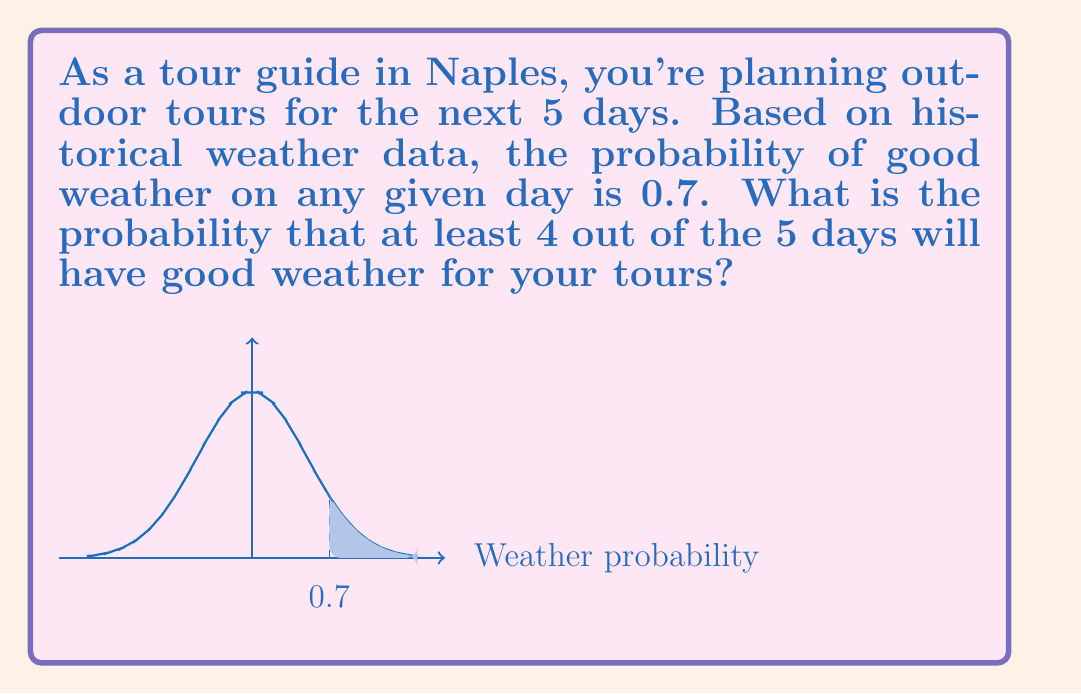Could you help me with this problem? Let's approach this step-by-step using the binomial probability distribution:

1) We can model this scenario as a binomial distribution with:
   $n = 5$ (number of days)
   $p = 0.7$ (probability of good weather on any day)
   $q = 1 - p = 0.3$ (probability of bad weather on any day)

2) We want the probability of at least 4 good weather days out of 5. This means we need to calculate:
   $P(X \geq 4)$ where $X$ is the number of good weather days

3) This is equivalent to:
   $P(X = 4) + P(X = 5)$

4) We can calculate these probabilities using the binomial probability formula:
   $P(X = k) = \binom{n}{k} p^k q^{n-k}$

5) For $P(X = 4)$:
   $P(X = 4) = \binom{5}{4} (0.7)^4 (0.3)^1$
   $= 5 \cdot (0.7)^4 \cdot (0.3)$
   $= 5 \cdot 0.2401 \cdot 0.3$
   $= 0.36015$

6) For $P(X = 5)$:
   $P(X = 5) = \binom{5}{5} (0.7)^5 (0.3)^0$
   $= 1 \cdot (0.7)^5$
   $= 0.16807$

7) Therefore, the total probability is:
   $P(X \geq 4) = P(X = 4) + P(X = 5)$
   $= 0.36015 + 0.16807$
   $= 0.52822$
Answer: 0.52822 